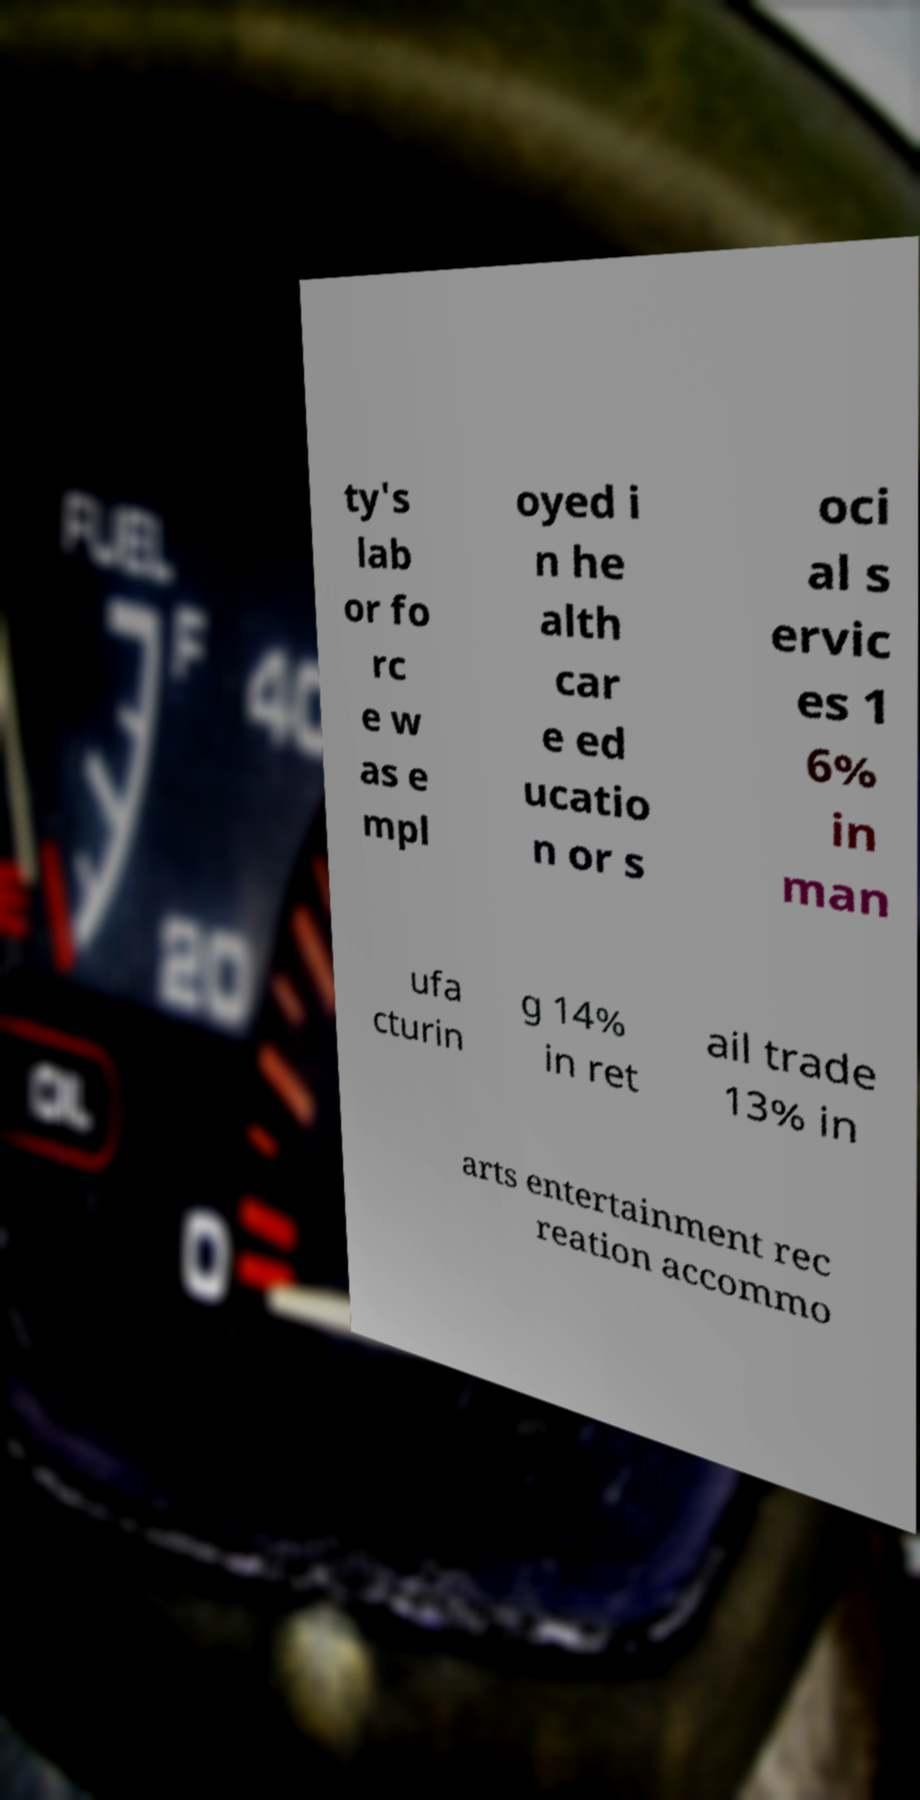What messages or text are displayed in this image? I need them in a readable, typed format. ty's lab or fo rc e w as e mpl oyed i n he alth car e ed ucatio n or s oci al s ervic es 1 6% in man ufa cturin g 14% in ret ail trade 13% in arts entertainment rec reation accommo 